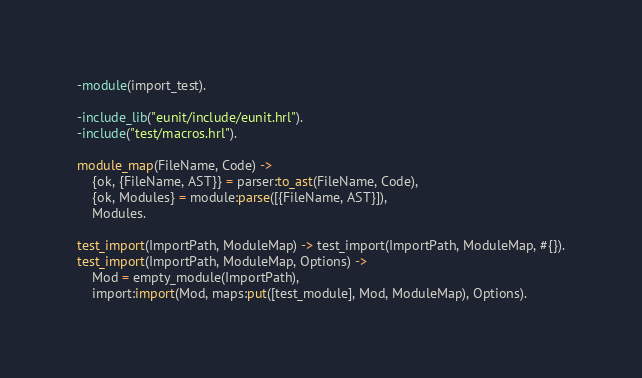<code> <loc_0><loc_0><loc_500><loc_500><_Erlang_>-module(import_test).

-include_lib("eunit/include/eunit.hrl").
-include("test/macros.hrl").

module_map(FileName, Code) -> 
    {ok, {FileName, AST}} = parser:to_ast(FileName, Code),
    {ok, Modules} = module:parse([{FileName, AST}]),
    Modules.

test_import(ImportPath, ModuleMap) -> test_import(ImportPath, ModuleMap, #{}).
test_import(ImportPath, ModuleMap, Options) ->
    Mod = empty_module(ImportPath),
    import:import(Mod, maps:put([test_module], Mod, ModuleMap), Options).
</code> 